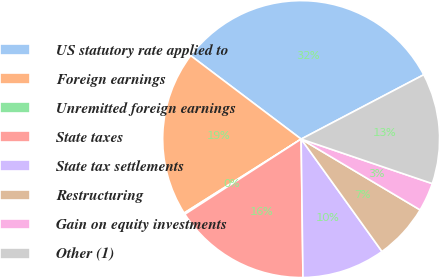<chart> <loc_0><loc_0><loc_500><loc_500><pie_chart><fcel>US statutory rate applied to<fcel>Foreign earnings<fcel>Unremitted foreign earnings<fcel>State taxes<fcel>State tax settlements<fcel>Restructuring<fcel>Gain on equity investments<fcel>Other (1)<nl><fcel>32.01%<fcel>19.27%<fcel>0.16%<fcel>16.08%<fcel>9.71%<fcel>6.53%<fcel>3.34%<fcel>12.9%<nl></chart> 